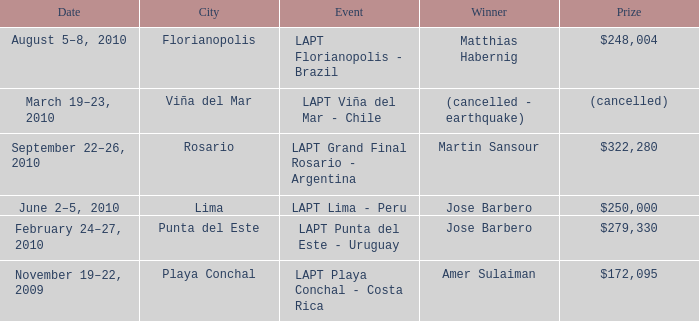Who is the winner in the city of lima? Jose Barbero. 